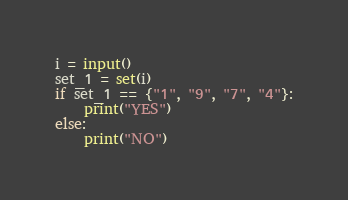Convert code to text. <code><loc_0><loc_0><loc_500><loc_500><_Python_>i = input()
set_1 = set(i)
if set_1 == {"1", "9", "7", "4"}:
    print("YES")
else:
    print("NO")</code> 